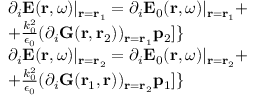<formula> <loc_0><loc_0><loc_500><loc_500>\begin{array} { r l } & { \partial _ { i } E ( r , \omega ) | _ { r = r _ { 1 } } = \partial _ { i } E _ { 0 } ( r , \omega ) | _ { r = r _ { 1 } } + } \\ & { + \frac { k _ { 0 } ^ { 2 } } { \epsilon _ { 0 } } ( \partial _ { i } G ( r , r _ { 2 } ) ) _ { r = r _ { 1 } } p _ { 2 } ] \} } \\ & { \partial _ { i } E ( r , \omega ) | _ { r = r _ { 2 } } = \partial _ { i } E _ { 0 } ( r , \omega ) | _ { r = r _ { 2 } } + } \\ & { + \frac { k _ { 0 } ^ { 2 } } { \epsilon _ { 0 } } ( \partial _ { i } G ( r _ { 1 } , r ) ) _ { r = r _ { 2 } } p _ { 1 } ] \} } \end{array}</formula> 